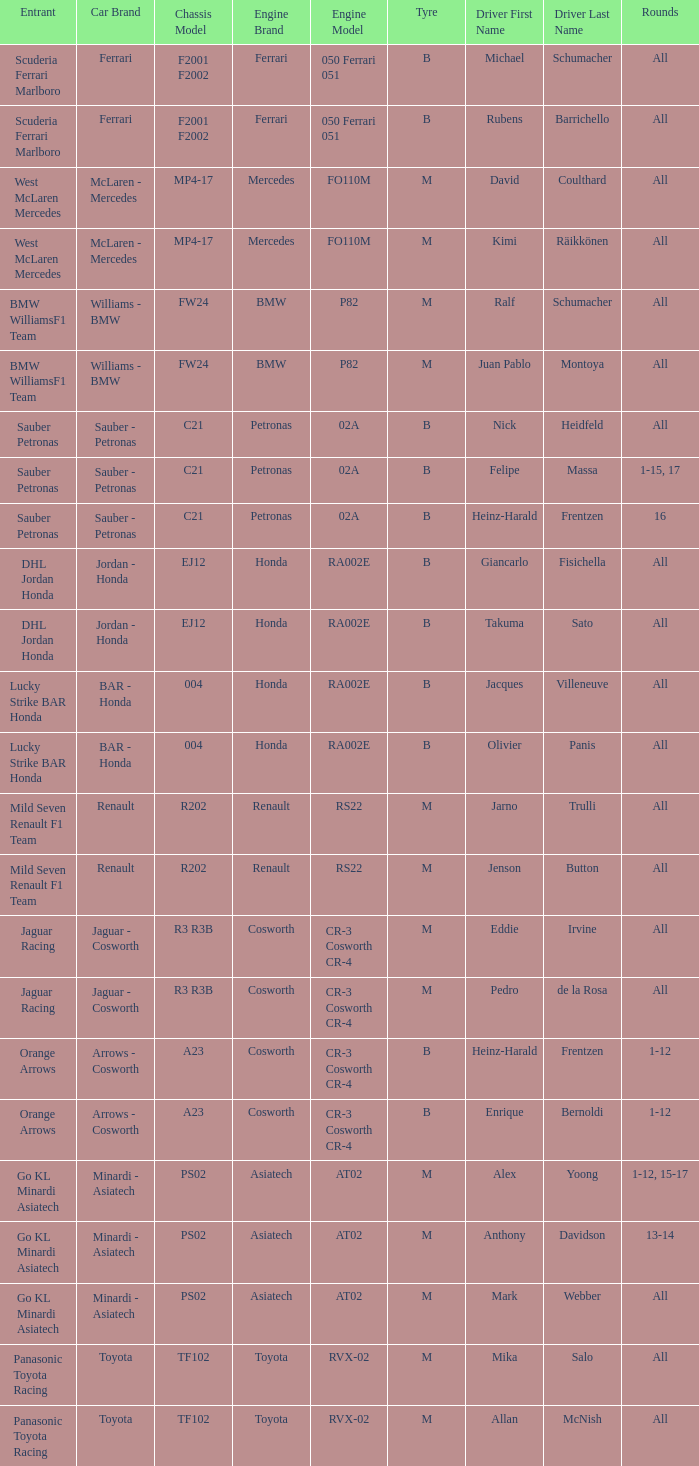Who is the driver when the engine is mercedes fo110m? David Coulthard, Kimi Räikkönen. 